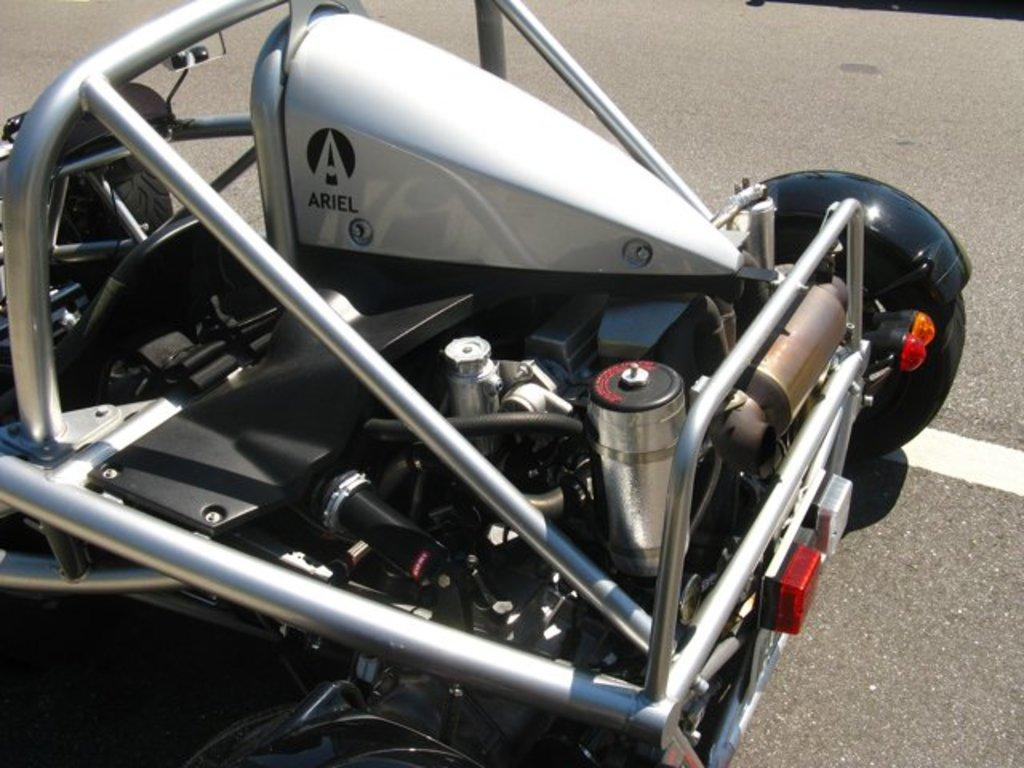What is the main subject of the image? There is a vehicle in the image. Where is the vehicle located? The vehicle is on the road. What can be seen on the vehicle? There are objects visible on the vehicle. What type of amusement can be seen on the vehicle in the image? There is no amusement present on the vehicle in the image. How much profit does the vehicle generate in the image? The image does not provide any information about the profit generated by the vehicle. 